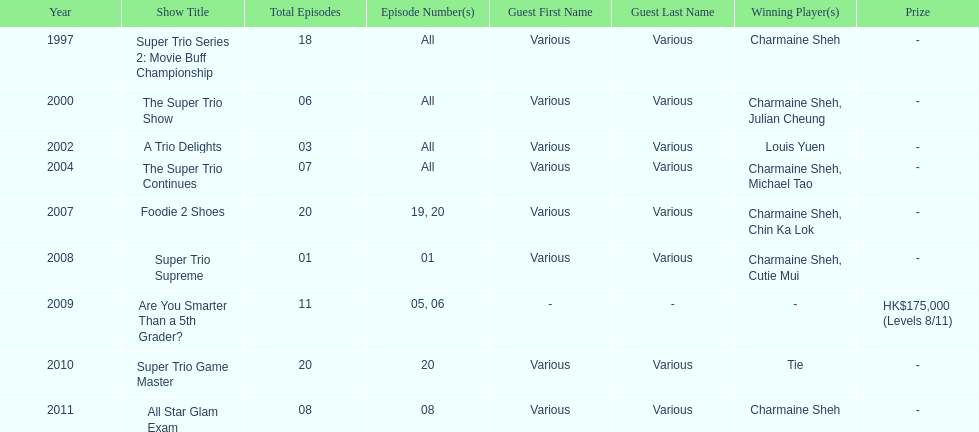How many of shows had at least 5 episodes? 7. 